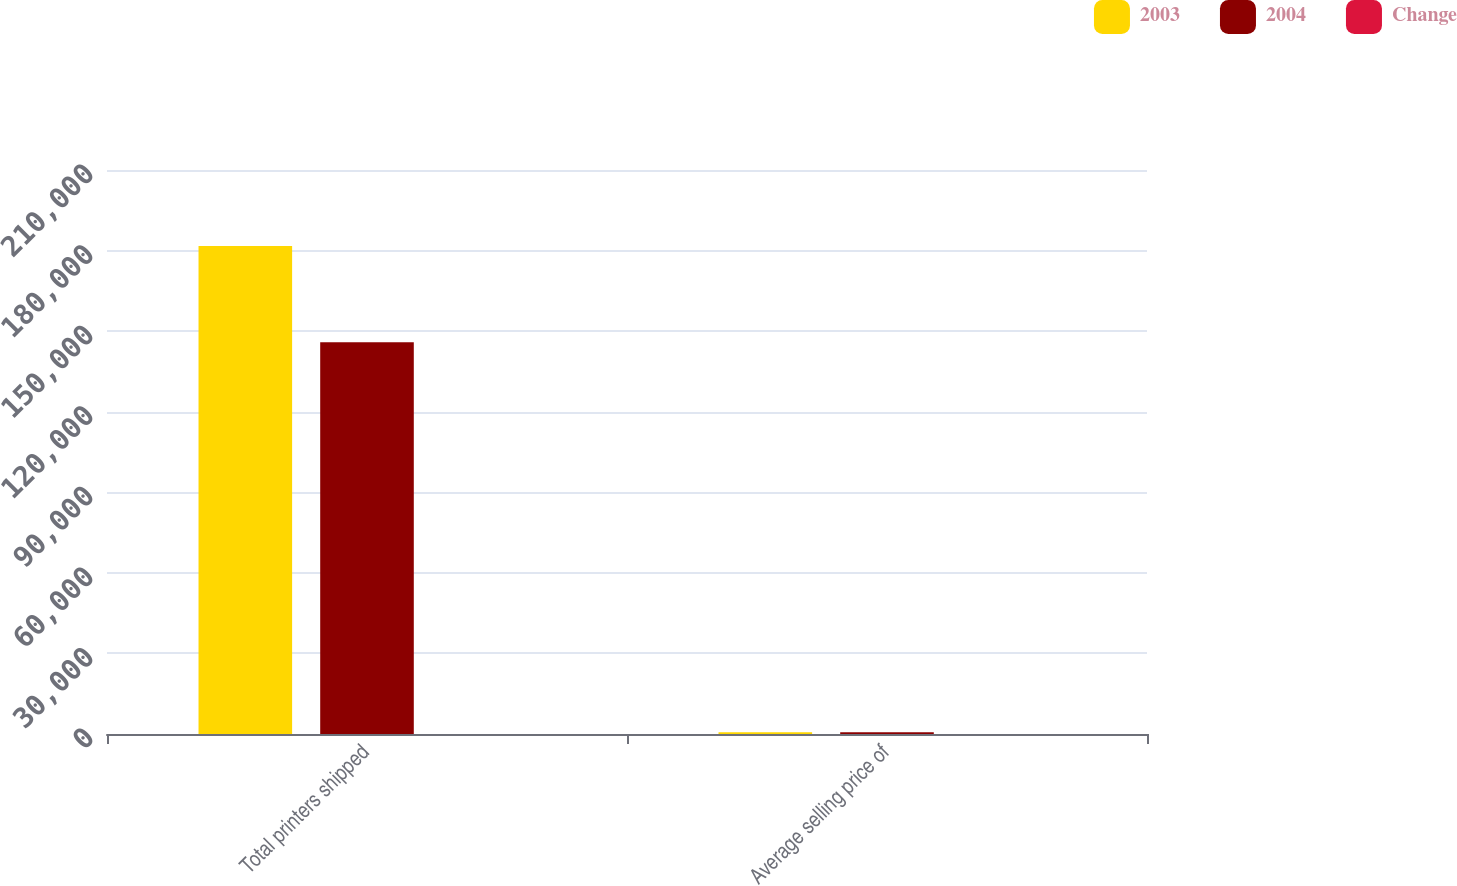Convert chart to OTSL. <chart><loc_0><loc_0><loc_500><loc_500><stacked_bar_chart><ecel><fcel>Total printers shipped<fcel>Average selling price of<nl><fcel>2003<fcel>181691<fcel>638<nl><fcel>2004<fcel>145834<fcel>640<nl><fcel>Change<fcel>24.6<fcel>0.3<nl></chart> 